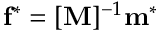<formula> <loc_0><loc_0><loc_500><loc_500>f ^ { * } = [ M ] ^ { - 1 } m ^ { * }</formula> 